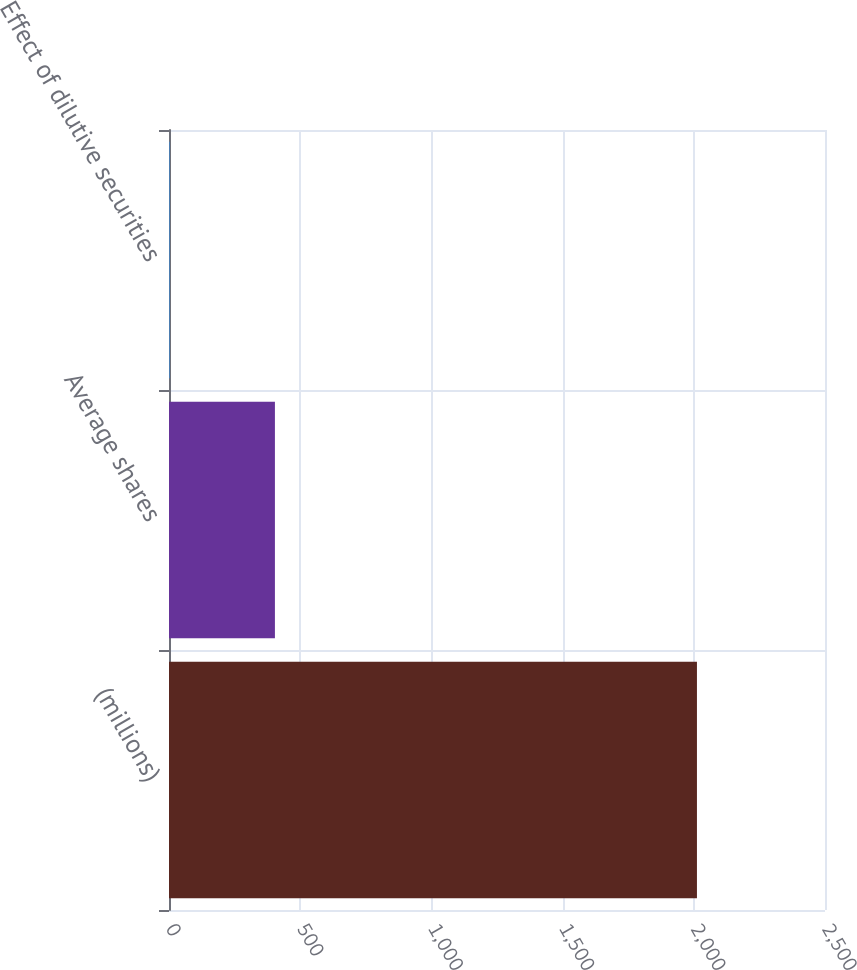<chart> <loc_0><loc_0><loc_500><loc_500><bar_chart><fcel>(millions)<fcel>Average shares<fcel>Effect of dilutive securities<nl><fcel>2012<fcel>403.68<fcel>1.6<nl></chart> 